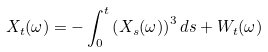Convert formula to latex. <formula><loc_0><loc_0><loc_500><loc_500>X _ { t } ( \omega ) = - \int ^ { t } _ { 0 } \left ( X _ { s } ( \omega ) \right ) ^ { 3 } d s + W _ { t } ( \omega )</formula> 